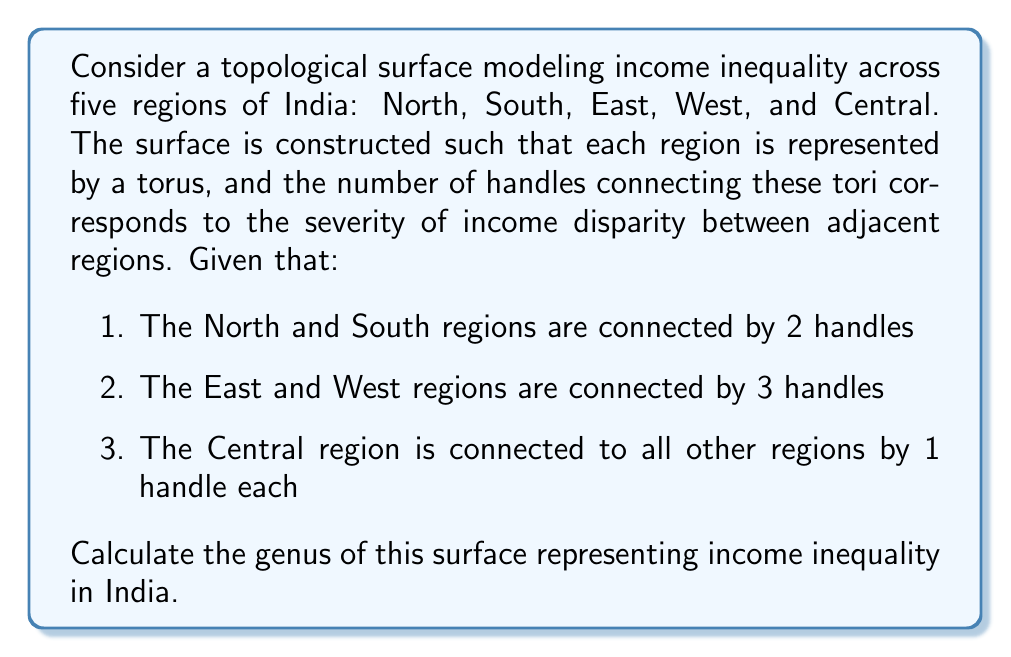Provide a solution to this math problem. To solve this problem, we need to understand the concept of genus in topology and how it applies to our model of income inequality in India. Let's break it down step-by-step:

1. Genus of a surface:
   The genus of a surface is the number of handles or "holes" it has. For a connected sum of tori, the genus is the sum of the genera of individual tori plus the number of additional handles connecting them.

2. Individual regions:
   Each region is represented by a torus, which has a genus of 1. We have 5 regions, so we start with:
   $$g_{\text{base}} = 5 \times 1 = 5$$

3. Additional handles:
   Now we count the additional handles connecting the regions:
   - North-South: 2 handles
   - East-West: 3 handles
   - Central to others: 4 handles (1 each to North, South, East, and West)
   
   Total additional handles: $$h_{\text{additional}} = 2 + 3 + 4 = 9$$

4. Calculate total genus:
   The total genus is the sum of the base genus and additional handles:
   $$g_{\text{total}} = g_{\text{base}} + h_{\text{additional}} = 5 + 9 = 14$$

This surface can be visualized as a complex interconnected structure with 14 handles, representing the intricate nature of income inequality across different regions of India.
Answer: The genus of the surface modeling income inequality across the five regions of India is 14. 